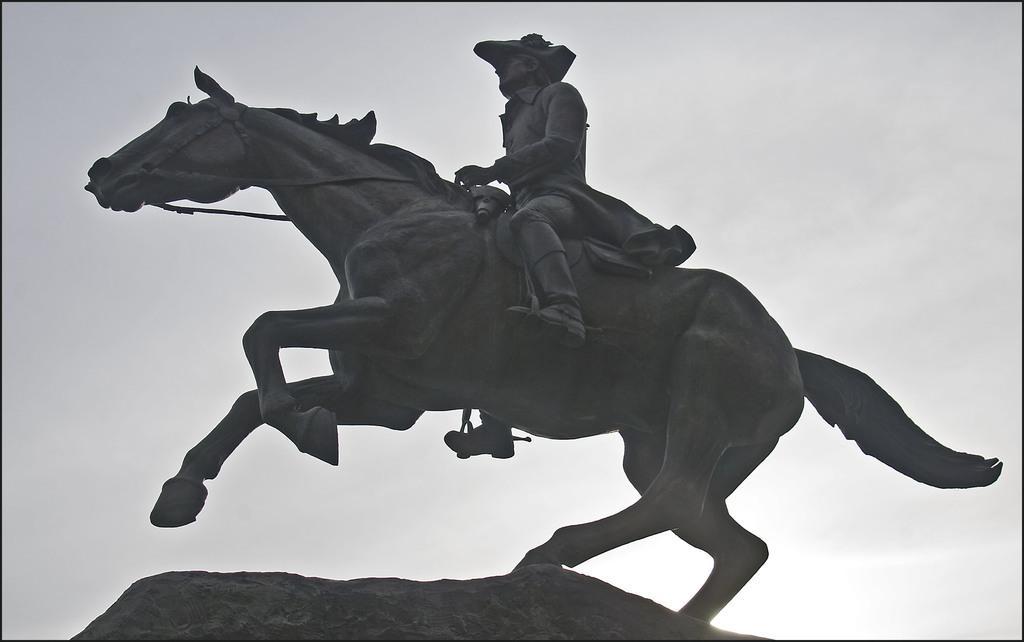Could you give a brief overview of what you see in this image? In this image there is a horse statue on which there is a man on it. 